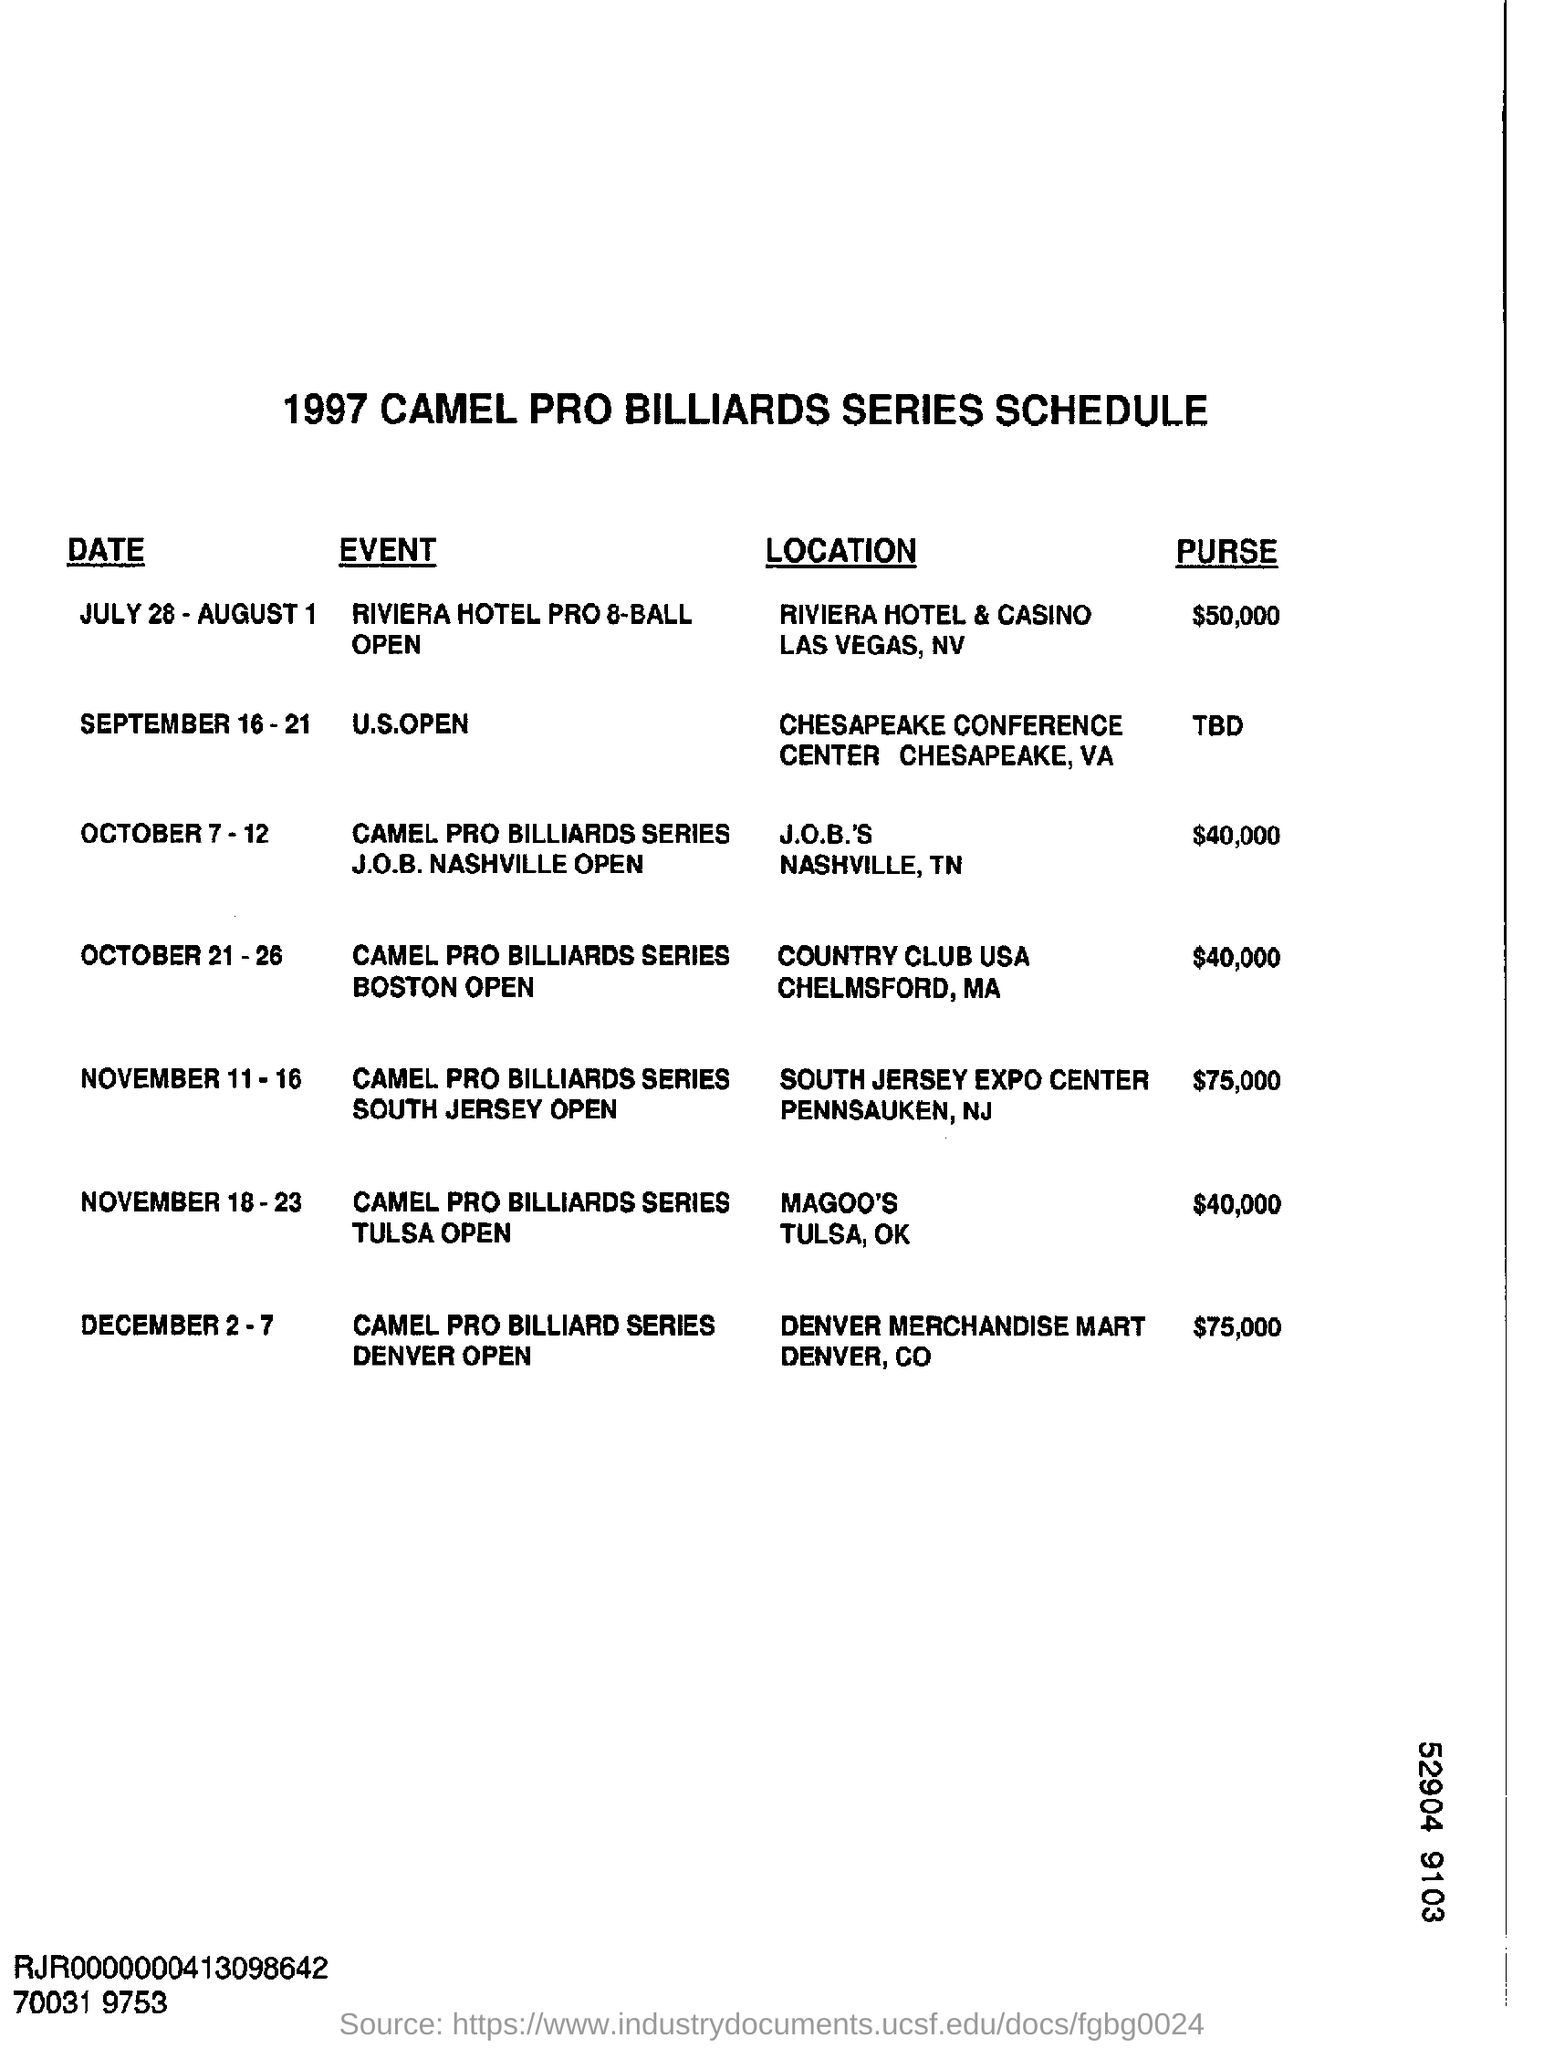Identify some key points in this picture. The U.S. Open event was conducted from September 16 to 21. The title of the document is "1997 CAMEL PRO BILLIARDS SERIES SCHEDULE. 